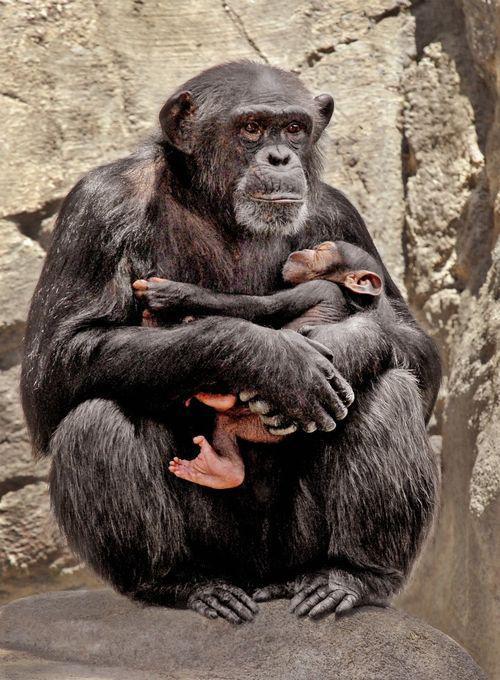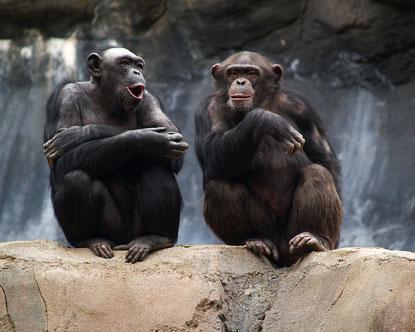The first image is the image on the left, the second image is the image on the right. Analyze the images presented: Is the assertion "At least one of the primates is smoking." valid? Answer yes or no. No. 